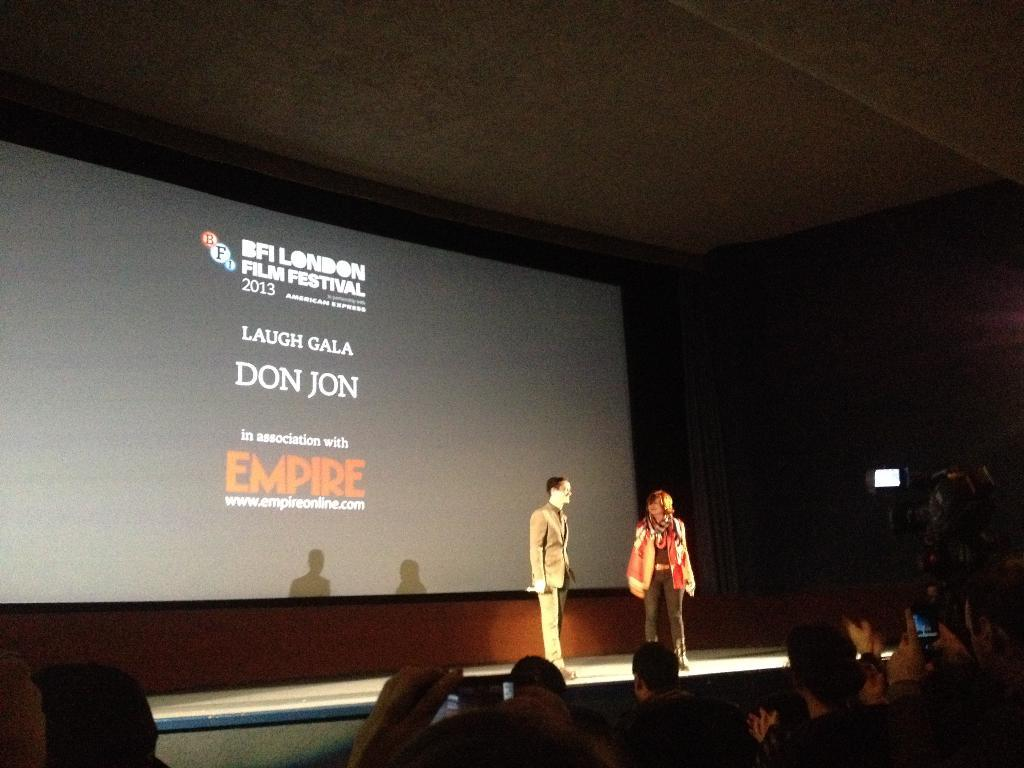How many people are present in the image? There are two people standing in the image, and there are also people sitting, so the total number of people is not specified. What are the sitting people doing in the image? Some of the sitting people are holding mobiles. What can be seen in the background of the image? There is a screen visible in the background of the image. What type of ray can be seen swimming in the image? There is no ray present in the image; it features people standing and sitting, holding mobiles, and a screen in the background. What ingredients are used to make the stew in the image? There is no stew present in the image; it features people and a screen in the background. 